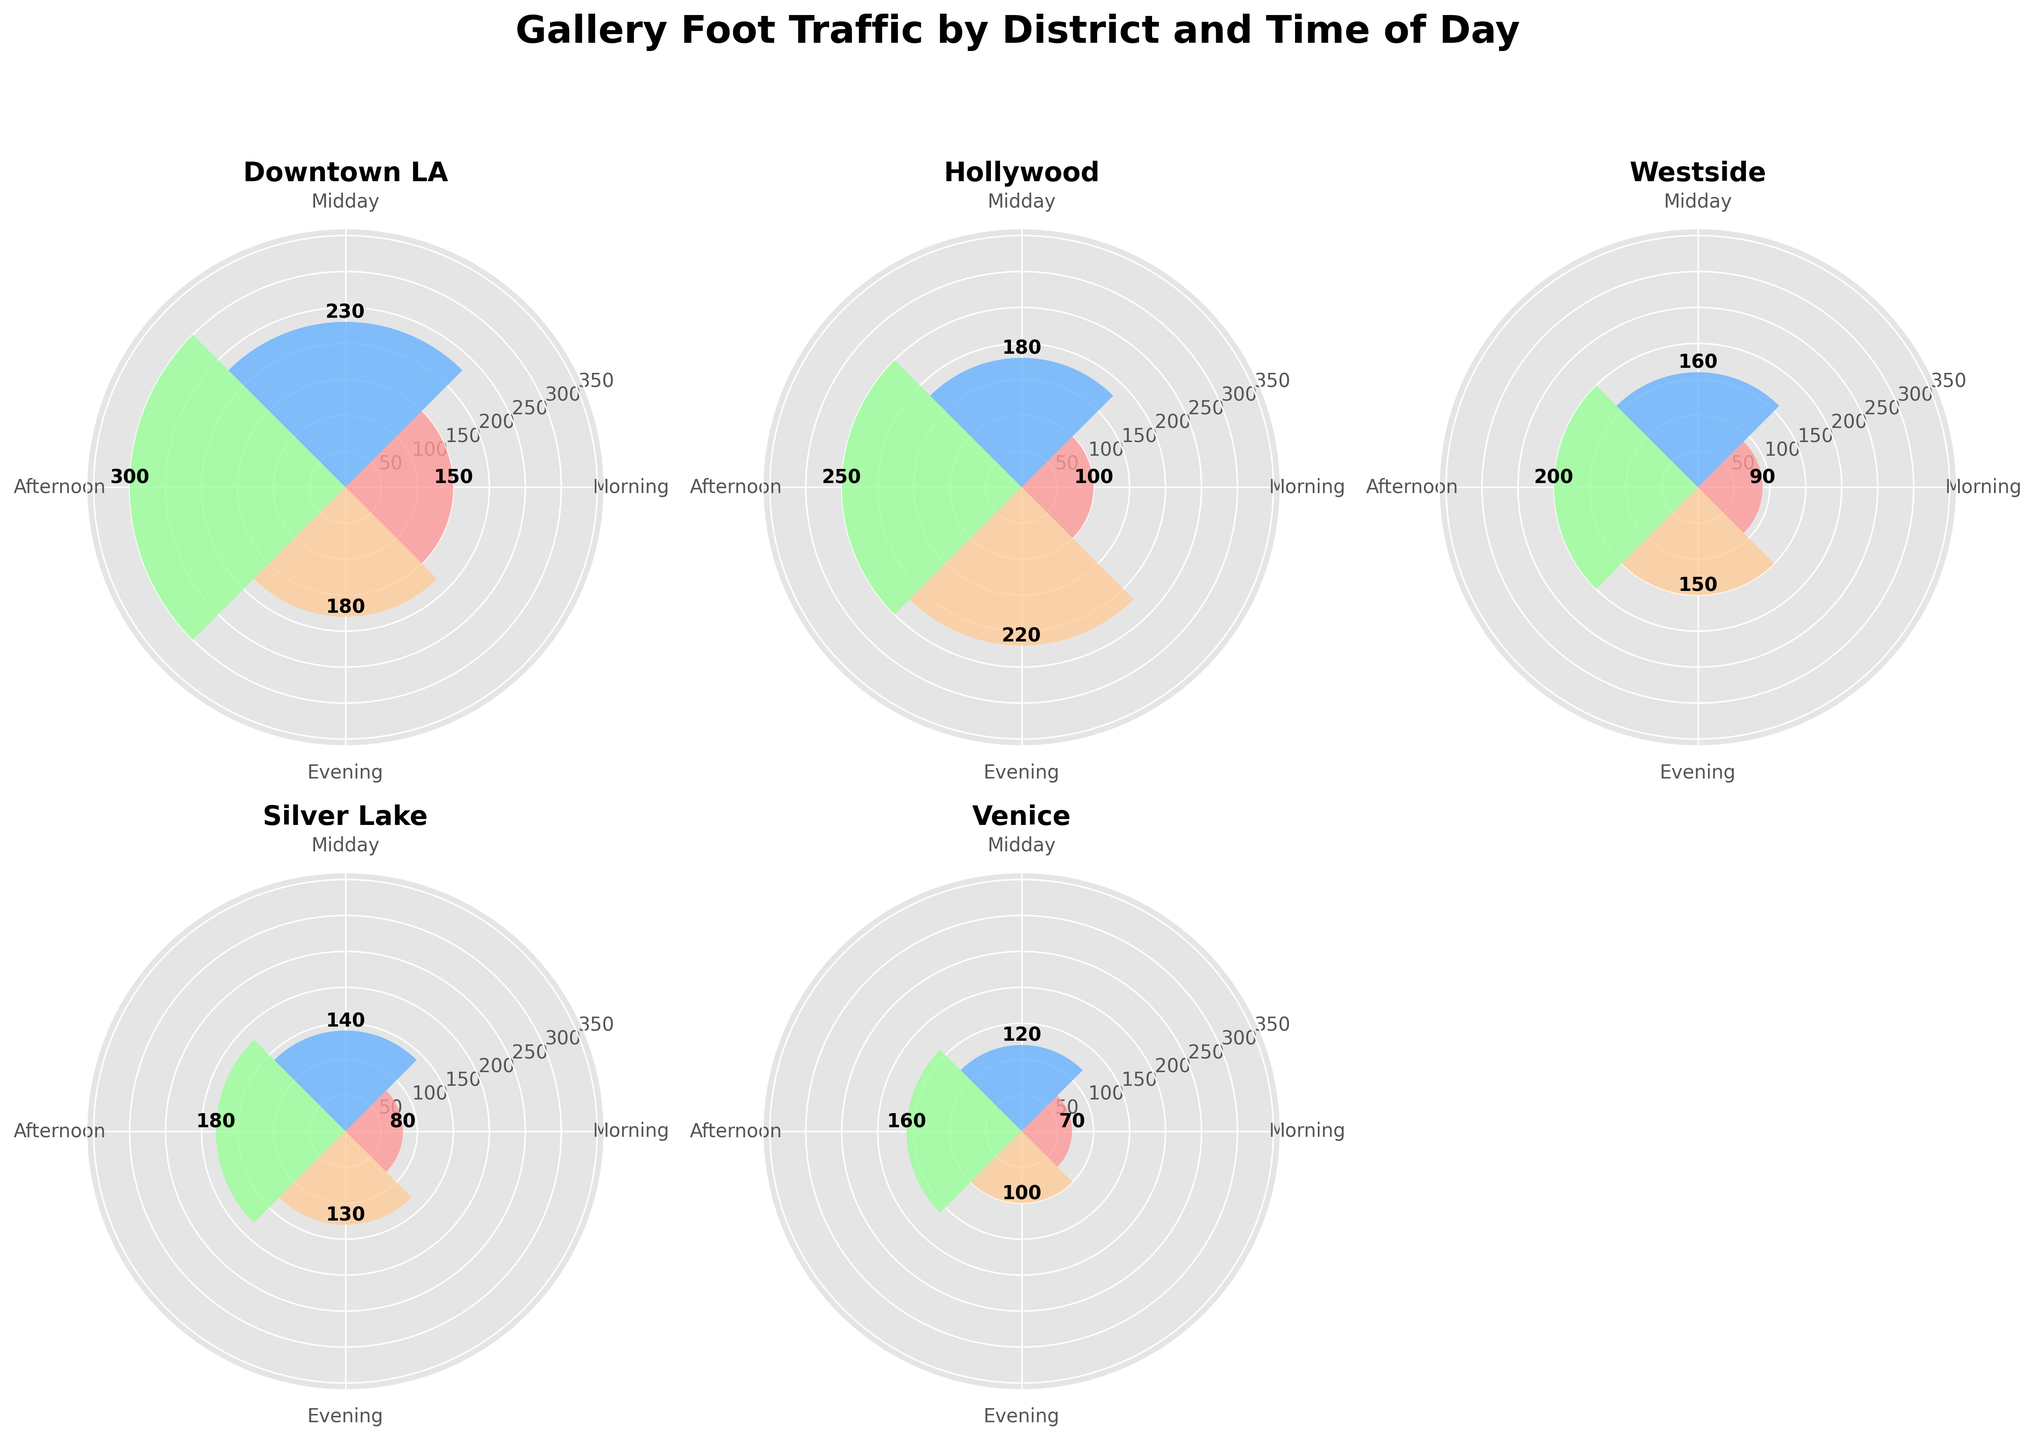What's the title of the figure? The title of the figure is given at the top and reads "Gallery Foot Traffic by District and Time of Day".
Answer: Gallery Foot Traffic by District and Time of Day Which district has the highest foot traffic in the afternoon? By looking at the height of the bars in the afternoon section for each district, Downtown LA has the highest foot traffic with a value of 300.
Answer: Downtown LA Which time of day has the least foot traffic in Venice? Venice has the smallest bar in the morning with a foot traffic value of 70.
Answer: Morning Comparing all districts, which has the most foot traffic during the evening? The highest bar in the evening across all the districts is in Hollywood with a value of 220.
Answer: Hollywood What's the total foot traffic in Downtown LA for the entire day? Sum the foot traffic values for all times of the day in Downtown LA: 150 (Morning) + 230 (Midday) + 300 (Afternoon) + 180 (Evening) = 860.
Answer: 860 What is the average foot traffic in Westside across all times of the day? Calculate the average by summing the foot traffic for all times and dividing by 4: (90 + 160 + 200 + 150) / 4 = 600 / 4 = 150.
Answer: 150 Is there any district that has uniform foot traffic throughout all times of the day? By comparing the lengths of the bars for each district across different times, no district has uniform foot traffic; all districts show variation.
Answer: No Which time period has the highest combined foot traffic across all districts? Calculate the sum of foot traffic across all districts for each time period: Morning (150 + 100 + 90 + 80 + 70), Midday (230 + 180 + 160 + 140 + 120), Afternoon (300 + 250 + 200 + 180 + 160), and Evening (180 + 220 + 150 + 130 + 100). The Afternoon has the highest combined value of 1090.
Answer: Afternoon How does Silver Lake's foot traffic in the Midday compare to Venice's foot traffic in the Afternoon? Silver Lake has a foot traffic value of 140 in the Midday, whereas Venice has a foot traffic value of 160 in the Afternoon. Comparing the two, Venice in the Afternoon has higher foot traffic by 20.
Answer: Venice has higher foot traffic by 20 What is the most common color used in the bars for all districts? The most common colors used are shades of red, blue, green, and orange, as indicated by the custom colormap created for the figure.
Answer: Red, blue, green, and orange 